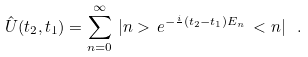<formula> <loc_0><loc_0><loc_500><loc_500>\hat { U } ( t _ { 2 } , t _ { 1 } ) = \sum _ { n = 0 } ^ { \infty } \, | n > \, e ^ { - \frac { i } { } ( t _ { 2 } - t _ { 1 } ) E _ { n } } \, < n | \ .</formula> 